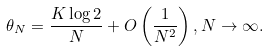Convert formula to latex. <formula><loc_0><loc_0><loc_500><loc_500>\theta _ { N } = \frac { K \log 2 } { N } + O \left ( \frac { 1 } { N ^ { 2 } } \right ) , N \rightarrow \infty .</formula> 